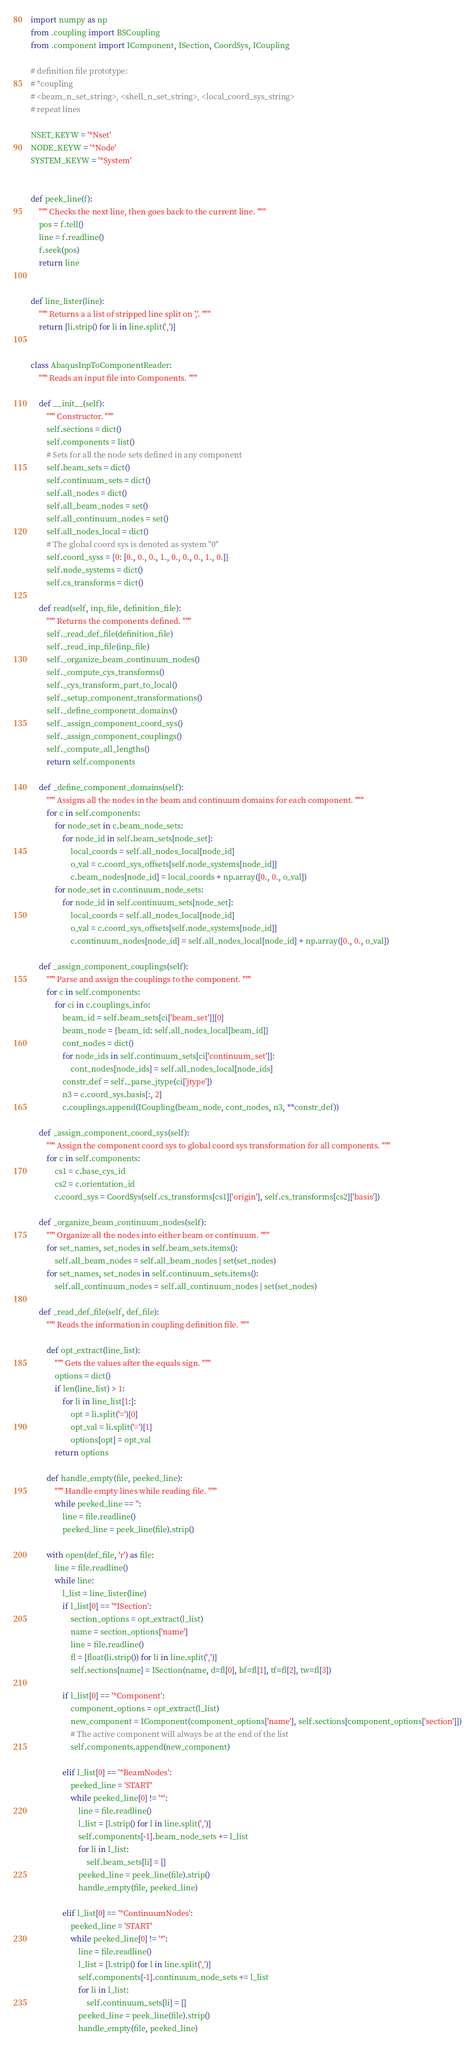Convert code to text. <code><loc_0><loc_0><loc_500><loc_500><_Python_>import numpy as np
from .coupling import BSCoupling
from .component import IComponent, ISection, CoordSys, ICoupling

# definition file prototype:
# *coupling
# <beam_n_set_string>, <shell_n_set_string>, <local_coord_sys_string>
# repeat lines

NSET_KEYW = '*Nset'
NODE_KEYW = '*Node'
SYSTEM_KEYW = '*System'


def peek_line(f):
    """ Checks the next line, then goes back to the current line. """
    pos = f.tell()
    line = f.readline()
    f.seek(pos)
    return line


def line_lister(line):
    """ Returns a a list of stripped line split on ','. """
    return [li.strip() for li in line.split(',')]


class AbaqusInpToComponentReader:
    """ Reads an input file into Components. """

    def __init__(self):
        """ Constructor. """
        self.sections = dict()
        self.components = list()
        # Sets for all the node sets defined in any component
        self.beam_sets = dict()
        self.continuum_sets = dict()
        self.all_nodes = dict()
        self.all_beam_nodes = set()
        self.all_continuum_nodes = set()
        self.all_nodes_local = dict()
        # The global coord sys is denoted as system "0"
        self.coord_syss = {0: [0., 0., 0., 1., 0., 0., 0., 1., 0.]}
        self.node_systems = dict()
        self.cs_transforms = dict()

    def read(self, inp_file, definition_file):
        """ Returns the components defined. """
        self._read_def_file(definition_file)
        self._read_inp_file(inp_file)
        self._organize_beam_continuum_nodes()
        self._compute_cys_transforms()
        self._cys_transform_part_to_local()
        self._setup_component_transformations()
        self._define_component_domains()
        self._assign_component_coord_sys()
        self._assign_component_couplings()
        self._compute_all_lengths()
        return self.components

    def _define_component_domains(self):
        """ Assigns all the nodes in the beam and continuum domains for each component. """
        for c in self.components:
            for node_set in c.beam_node_sets:
                for node_id in self.beam_sets[node_set]:
                    local_coords = self.all_nodes_local[node_id]
                    o_val = c.coord_sys_offsets[self.node_systems[node_id]]
                    c.beam_nodes[node_id] = local_coords + np.array([0., 0., o_val])
            for node_set in c.continuum_node_sets:
                for node_id in self.continuum_sets[node_set]:
                    local_coords = self.all_nodes_local[node_id]
                    o_val = c.coord_sys_offsets[self.node_systems[node_id]]
                    c.continuum_nodes[node_id] = self.all_nodes_local[node_id] + np.array([0., 0., o_val])

    def _assign_component_couplings(self):
        """ Parse and assign the couplings to the component. """
        for c in self.components:
            for ci in c.couplings_info:
                beam_id = self.beam_sets[ci['beam_set']][0]
                beam_node = {beam_id: self.all_nodes_local[beam_id]}
                cont_nodes = dict()
                for node_ids in self.continuum_sets[ci['continuum_set']]:
                    cont_nodes[node_ids] = self.all_nodes_local[node_ids]
                constr_def = self._parse_jtype(ci['jtype'])
                n3 = c.coord_sys.basis[:, 2]
                c.couplings.append(ICoupling(beam_node, cont_nodes, n3, **constr_def))

    def _assign_component_coord_sys(self):
        """ Assign the component coord sys to global coord sys transformation for all components. """
        for c in self.components:
            cs1 = c.base_cys_id
            cs2 = c.orientation_id
            c.coord_sys = CoordSys(self.cs_transforms[cs1]['origin'], self.cs_transforms[cs2]['basis'])

    def _organize_beam_continuum_nodes(self):
        """ Organize all the nodes into either beam or continuum. """
        for set_names, set_nodes in self.beam_sets.items():
            self.all_beam_nodes = self.all_beam_nodes | set(set_nodes)
        for set_names, set_nodes in self.continuum_sets.items():
            self.all_continuum_nodes = self.all_continuum_nodes | set(set_nodes)

    def _read_def_file(self, def_file):
        """ Reads the information in coupling definition file. """

        def opt_extract(line_list):
            """ Gets the values after the equals sign. """
            options = dict()
            if len(line_list) > 1:
                for li in line_list[1:]:
                    opt = li.split('=')[0]
                    opt_val = li.split('=')[1]
                    options[opt] = opt_val
            return options

        def handle_empty(file, peeked_line):
            """ Handle empty lines while reading file. """
            while peeked_line == '':
                line = file.readline()
                peeked_line = peek_line(file).strip()

        with open(def_file, 'r') as file:
            line = file.readline()
            while line:
                l_list = line_lister(line)
                if l_list[0] == '*ISection':
                    section_options = opt_extract(l_list)
                    name = section_options['name']
                    line = file.readline()
                    fl = [float(li.strip()) for li in line.split(',')]
                    self.sections[name] = ISection(name, d=fl[0], bf=fl[1], tf=fl[2], tw=fl[3])

                if l_list[0] == '*Component':
                    component_options = opt_extract(l_list)
                    new_component = IComponent(component_options['name'], self.sections[component_options['section']])
                    # The active component will always be at the end of the list
                    self.components.append(new_component)

                elif l_list[0] == '*BeamNodes':
                    peeked_line = 'START'
                    while peeked_line[0] != '*':
                        line = file.readline()
                        l_list = [l.strip() for l in line.split(',')]
                        self.components[-1].beam_node_sets += l_list
                        for li in l_list:
                            self.beam_sets[li] = []
                        peeked_line = peek_line(file).strip()
                        handle_empty(file, peeked_line)

                elif l_list[0] == '*ContinuumNodes':
                    peeked_line = 'START'
                    while peeked_line[0] != '*':
                        line = file.readline()
                        l_list = [l.strip() for l in line.split(',')]
                        self.components[-1].continuum_node_sets += l_list
                        for li in l_list:
                            self.continuum_sets[li] = []
                        peeked_line = peek_line(file).strip()
                        handle_empty(file, peeked_line)
</code> 